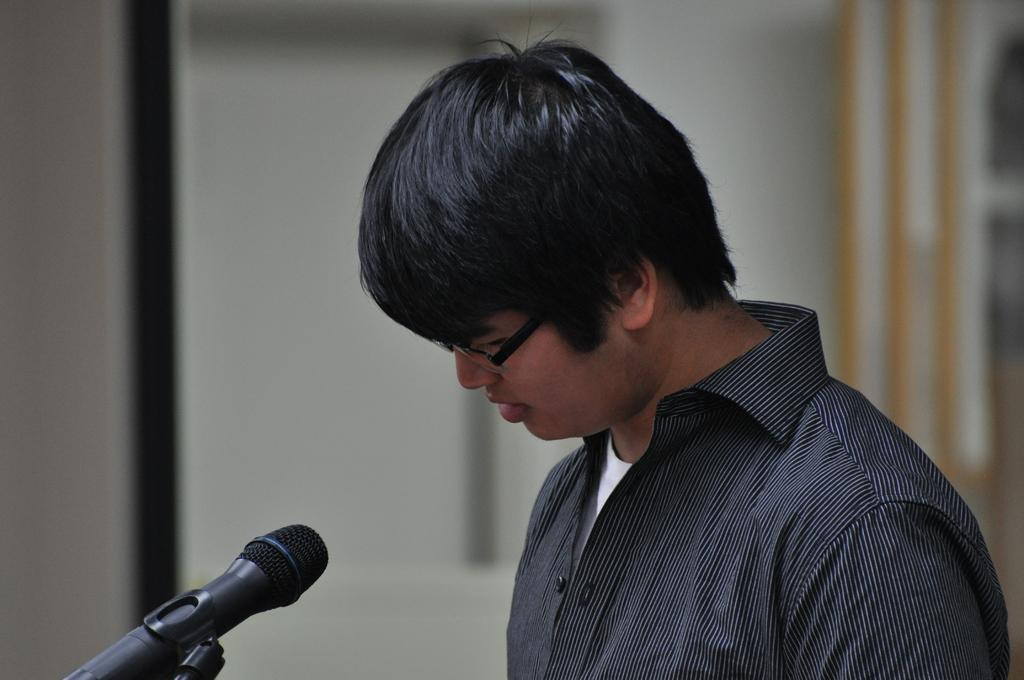Who is the main subject in the image? There is a man in the image. What is the man wearing? The man is wearing a black shirt. What object is in front of the man? There is a microphone with a stand in front of the man. What can be seen behind the man? There is a wall in the background of the image. How is the background of the image depicted? The background is blurred. Can you see any deer in the image? No, there are no deer present in the image. What suggestion does the man have for the audience in the image? The image does not provide any information about a suggestion from the man, as it only shows him standing in front of a microphone with a blurred background. 